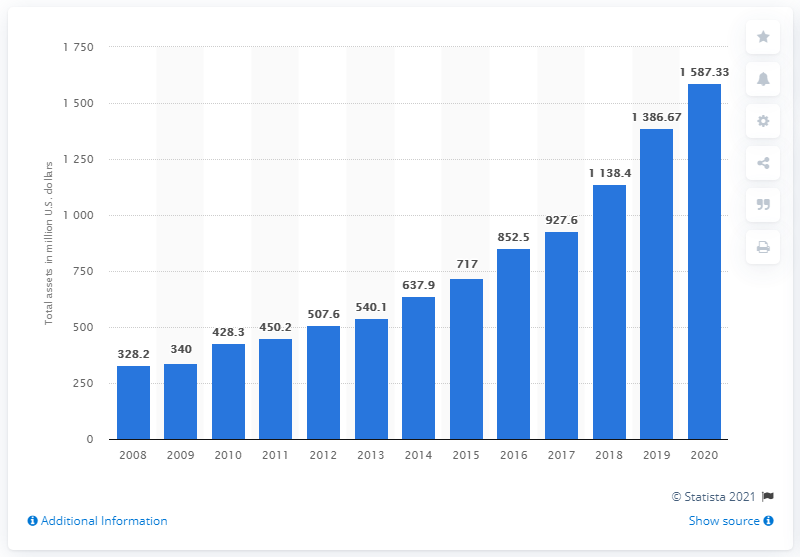Indicate a few pertinent items in this graphic. Choice Hotels International Inc.'s assets during the 2020 financial year were valued at 1587.33. The total assets of Choice Hotels International Inc. for the previous year were 1386.67. 